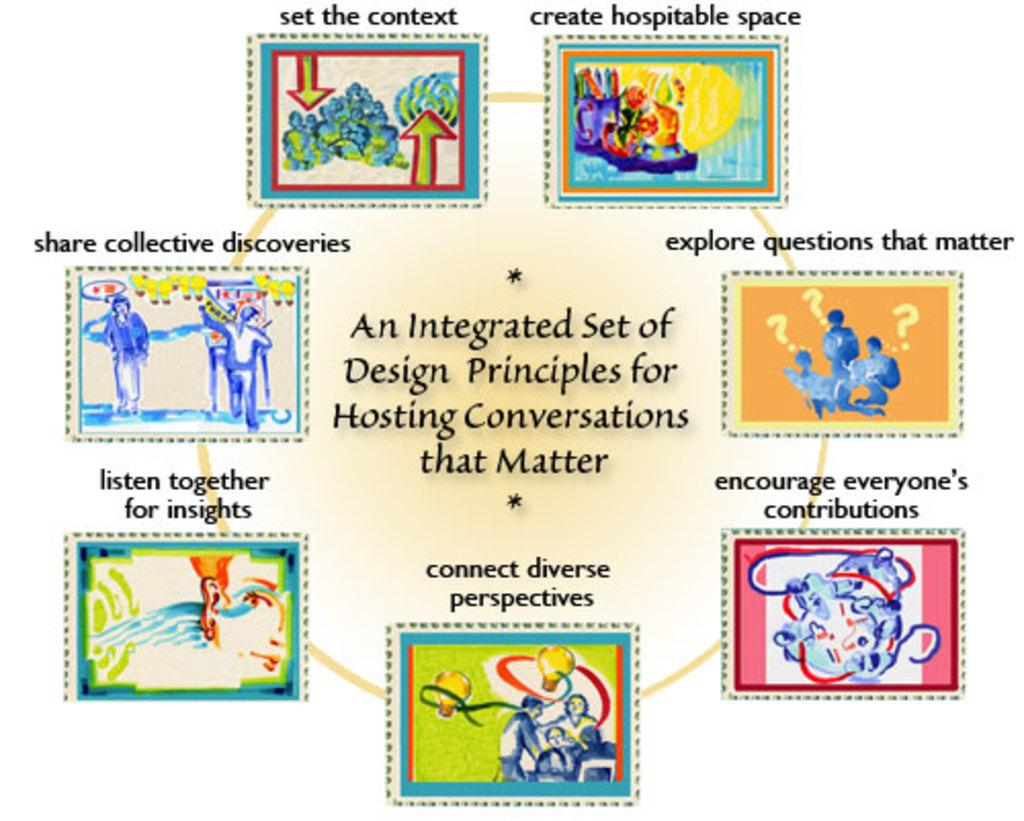Provide a one-sentence caption for the provided image. a colorful graph shows you how to host conversations that matter. 